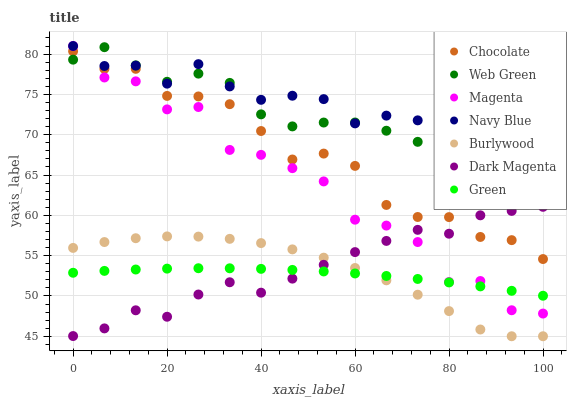Does Green have the minimum area under the curve?
Answer yes or no. Yes. Does Navy Blue have the maximum area under the curve?
Answer yes or no. Yes. Does Burlywood have the minimum area under the curve?
Answer yes or no. No. Does Burlywood have the maximum area under the curve?
Answer yes or no. No. Is Green the smoothest?
Answer yes or no. Yes. Is Magenta the roughest?
Answer yes or no. Yes. Is Burlywood the smoothest?
Answer yes or no. No. Is Burlywood the roughest?
Answer yes or no. No. Does Burlywood have the lowest value?
Answer yes or no. Yes. Does Navy Blue have the lowest value?
Answer yes or no. No. Does Magenta have the highest value?
Answer yes or no. Yes. Does Burlywood have the highest value?
Answer yes or no. No. Is Green less than Chocolate?
Answer yes or no. Yes. Is Navy Blue greater than Burlywood?
Answer yes or no. Yes. Does Dark Magenta intersect Magenta?
Answer yes or no. Yes. Is Dark Magenta less than Magenta?
Answer yes or no. No. Is Dark Magenta greater than Magenta?
Answer yes or no. No. Does Green intersect Chocolate?
Answer yes or no. No. 